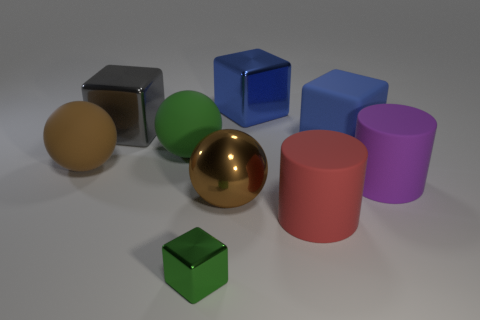Which object in the image appears to be most reflective? The object that appears most reflective in the image is the sphere with a shiny, metallic surface located towards the center. Its high gloss finish and clear reflection of the environment around it make it stand out as the most reflective among the displayed objects. 